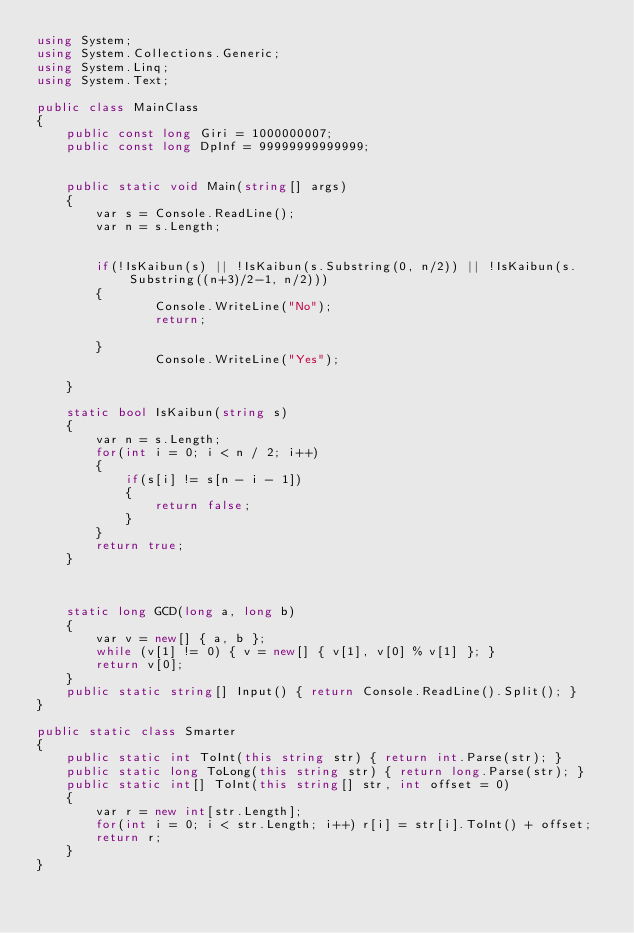Convert code to text. <code><loc_0><loc_0><loc_500><loc_500><_C#_>using System;
using System.Collections.Generic;
using System.Linq;
using System.Text;

public class MainClass
{
	public const long Giri = 1000000007;
	public const long DpInf = 99999999999999;
	
	
	public static void Main(string[] args)
	{
 		var s = Console.ReadLine();
 		var n = s.Length;
 		
 		
 		if(!IsKaibun(s) || !IsKaibun(s.Substring(0, n/2)) || !IsKaibun(s.Substring((n+3)/2-1, n/2)))
 		{
 				Console.WriteLine("No");
 				return;
 		
 		}
 				Console.WriteLine("Yes");
 		
	}
	
	static bool IsKaibun(string s)
	{
		var n = s.Length;
		for(int i = 0; i < n / 2; i++)
 		{
 			if(s[i] != s[n - i - 1])
 			{
 				return false;
 			}
 		}
 		return true;
	}
	
	
	
	static long GCD(long a, long b)
	{
		var v = new[] { a, b };
		while (v[1] != 0) { v = new[] { v[1], v[0] % v[1] }; }
		return v[0];
	}
	public static string[] Input() { return Console.ReadLine().Split(); }
}

public static class Smarter
{
	public static int ToInt(this string str) { return int.Parse(str); }
	public static long ToLong(this string str) { return long.Parse(str); }
	public static int[] ToInt(this string[] str, int offset = 0)
	{
		var r = new int[str.Length];
		for(int i = 0; i < str.Length; i++) r[i] = str[i].ToInt() + offset;
		return r;
	}
}</code> 